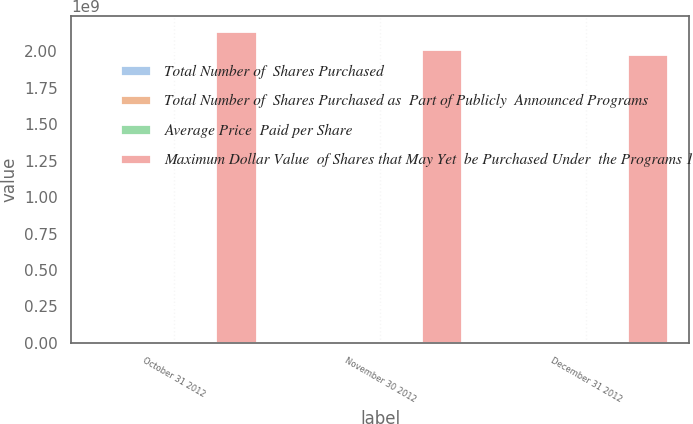Convert chart to OTSL. <chart><loc_0><loc_0><loc_500><loc_500><stacked_bar_chart><ecel><fcel>October 31 2012<fcel>November 30 2012<fcel>December 31 2012<nl><fcel>Total Number of  Shares Purchased<fcel>2.1e+06<fcel>2.4e+06<fcel>665000<nl><fcel>Total Number of  Shares Purchased as  Part of Publicly  Announced Programs<fcel>48.67<fcel>49.81<fcel>52.07<nl><fcel>Average Price  Paid per Share<fcel>2.1e+06<fcel>2.4e+06<fcel>665000<nl><fcel>Maximum Dollar Value  of Shares that May Yet  be Purchased Under  the Programs 1<fcel>2.13711e+09<fcel>2.01757e+09<fcel>1.98294e+09<nl></chart> 